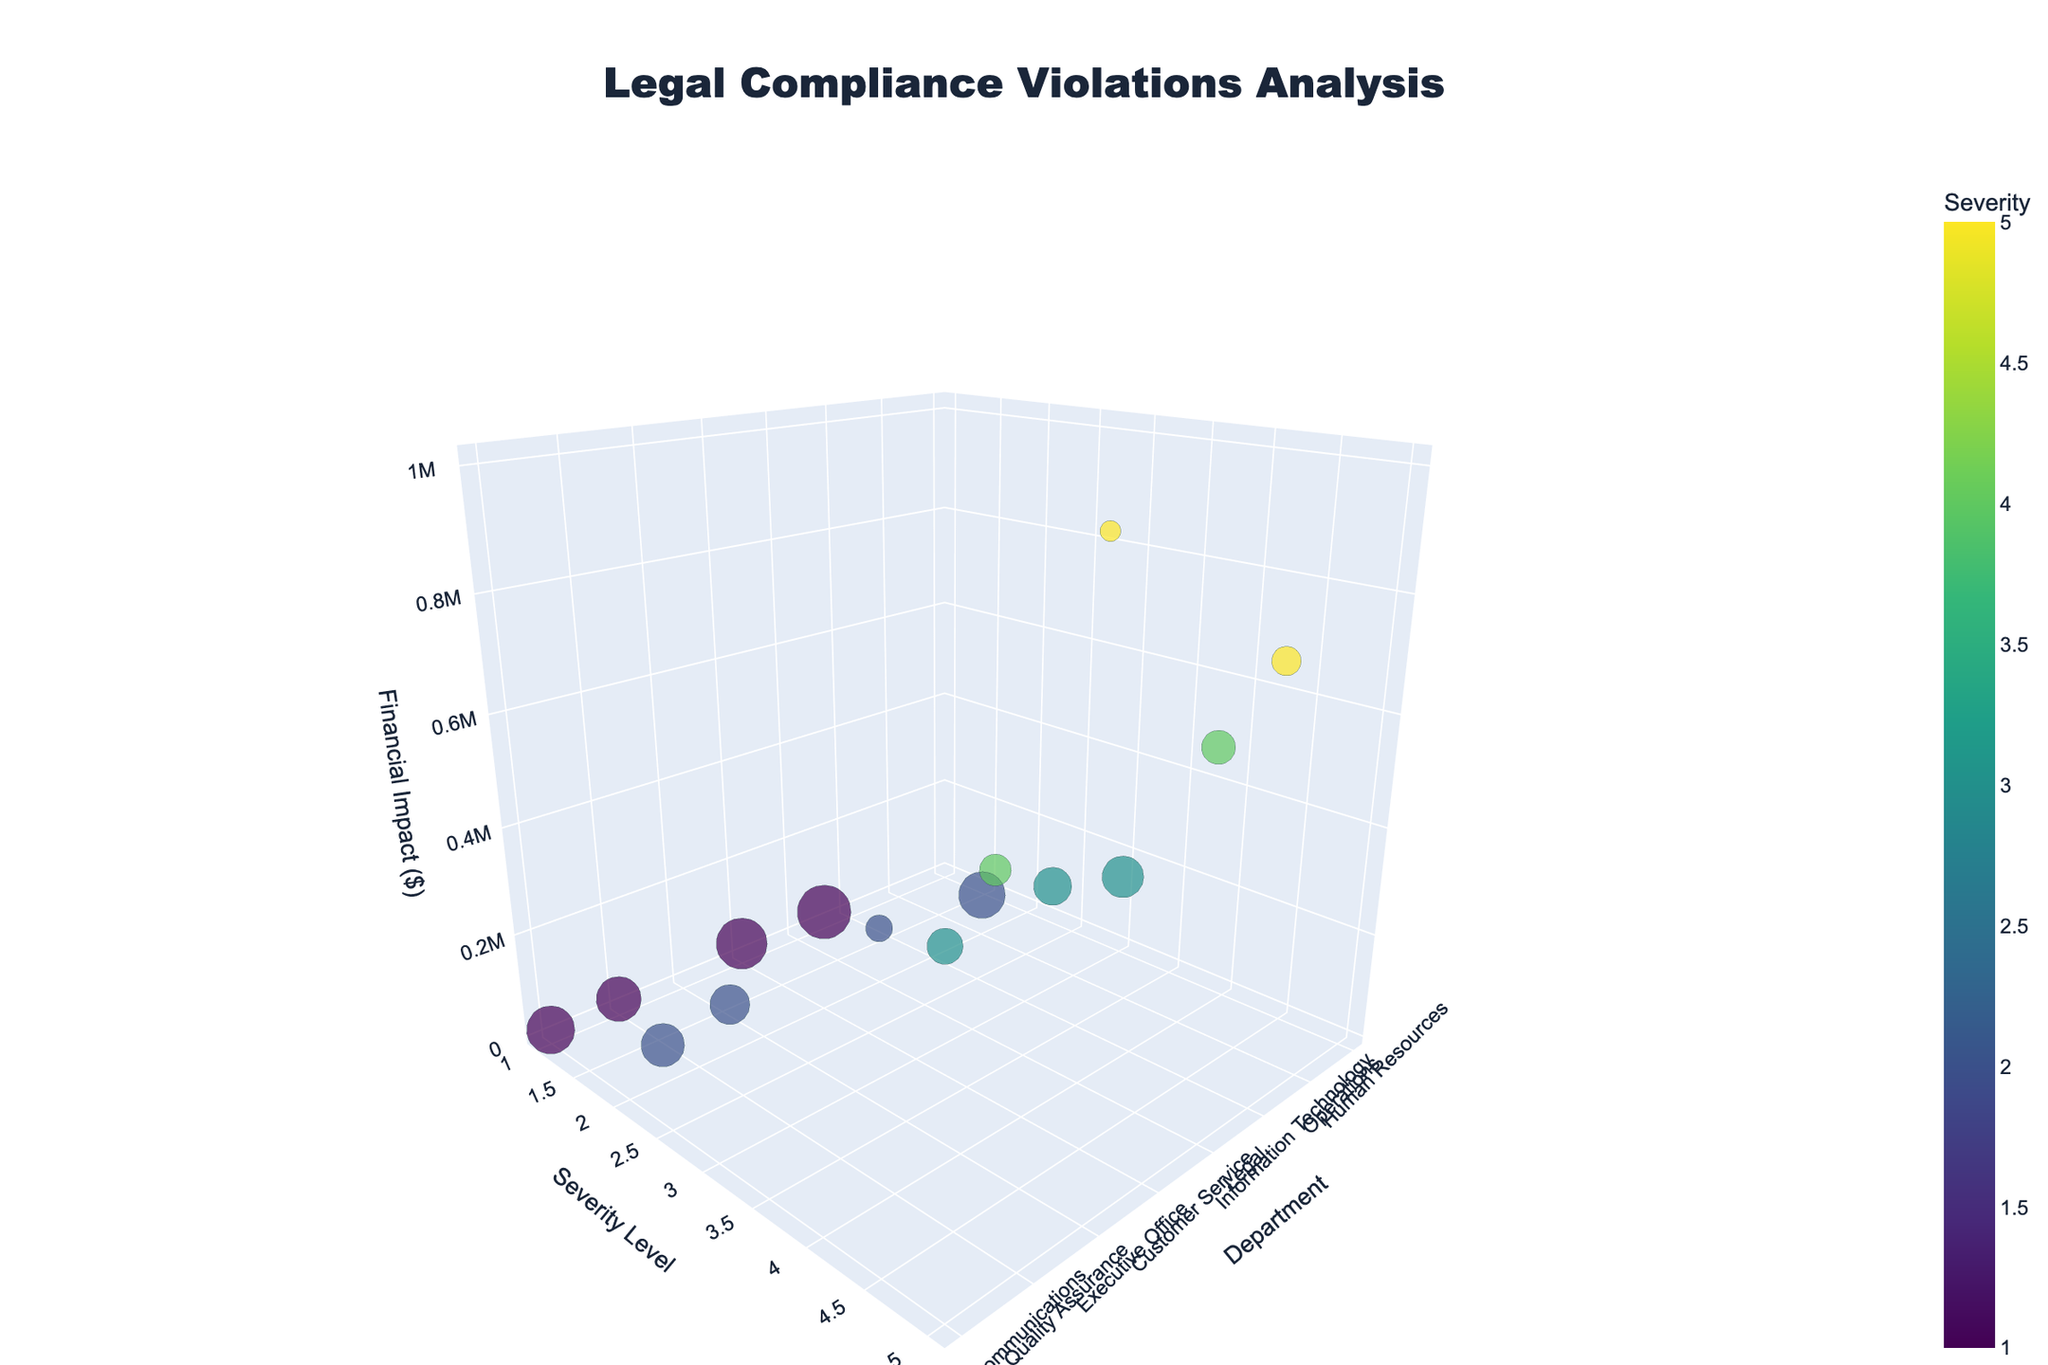What is the title of the figure? The title is typically located at the top of the figure and summarizes the main topic. In this instance, the title provides insight into what the chart represents.
Answer: Legal Compliance Violations Analysis How many departments have a severity level of 1? Inspect the severity level axis (y-axis) and count the bubbles located at level 1.
Answer: 4 Which department has the highest financial impact from violations? Look for the bubble that has the highest value on the financial impact axis (z-axis).
Answer: Executive Office Which department has the greatest number of violations? The size of the bubbles indicates the number of violations, so locate the largest bubble.
Answer: Marketing Are there any departments with the same severity level but different financial impacts? Compare the positions along the severity axis with the positions along the financial impact axis for each bubble.
Answer: Yes How does the financial impact from violations in Operations compare to Finance? Compare the z-axis values of the bubbles for Operations and Finance departments.
Answer: Operations ($75,000) < Finance ($500,000) Which department faces both high severity level and high financial impact? Locate a bubble at the upper levels of both severity and financial impact axes.
Answer: Information Technology How many departments have a severity level equal to 2? Inspect the bubbles at severity level 2 on the severity axis and count them.
Answer: 4 